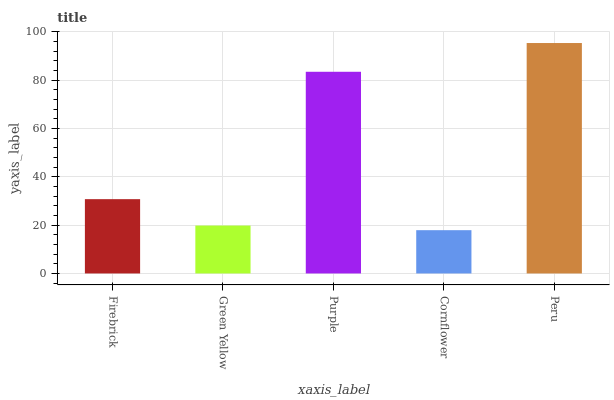Is Cornflower the minimum?
Answer yes or no. Yes. Is Peru the maximum?
Answer yes or no. Yes. Is Green Yellow the minimum?
Answer yes or no. No. Is Green Yellow the maximum?
Answer yes or no. No. Is Firebrick greater than Green Yellow?
Answer yes or no. Yes. Is Green Yellow less than Firebrick?
Answer yes or no. Yes. Is Green Yellow greater than Firebrick?
Answer yes or no. No. Is Firebrick less than Green Yellow?
Answer yes or no. No. Is Firebrick the high median?
Answer yes or no. Yes. Is Firebrick the low median?
Answer yes or no. Yes. Is Peru the high median?
Answer yes or no. No. Is Cornflower the low median?
Answer yes or no. No. 